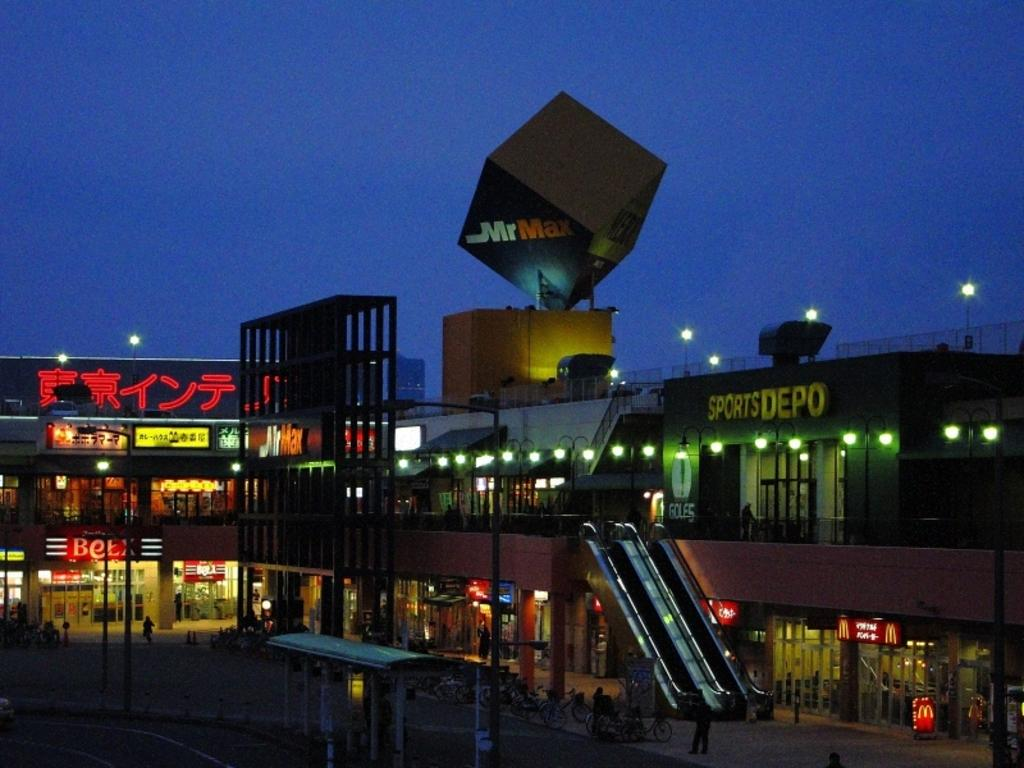At what time of day was the image taken? The image was taken during night time. What can be seen in the center of the image? There are buildings in the center of the image. What is visible in the image that provides illumination? Lights are present in the image. What type of signage is visible in the image? Boards and banners are visible in the image. What mode of transportation is present in the image? An escalator is present in the image. Are there any people in the image? Yes, there are people in the image. What other objects can be seen in the image? Other objects are present in the image. What type of fowl can be seen flying over the buildings in the image? There is no fowl visible in the image; the image was taken during night time, and fowl are not typically active in the dark. What type of engine is powering the escalator in the image? The image does not provide information about the type of engine powering the escalator; it only shows the escalator itself. 